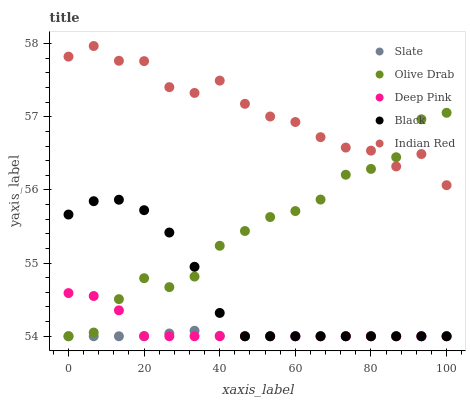Does Slate have the minimum area under the curve?
Answer yes or no. Yes. Does Indian Red have the maximum area under the curve?
Answer yes or no. Yes. Does Deep Pink have the minimum area under the curve?
Answer yes or no. No. Does Deep Pink have the maximum area under the curve?
Answer yes or no. No. Is Slate the smoothest?
Answer yes or no. Yes. Is Indian Red the roughest?
Answer yes or no. Yes. Is Deep Pink the smoothest?
Answer yes or no. No. Is Deep Pink the roughest?
Answer yes or no. No. Does Slate have the lowest value?
Answer yes or no. Yes. Does Indian Red have the lowest value?
Answer yes or no. No. Does Indian Red have the highest value?
Answer yes or no. Yes. Does Deep Pink have the highest value?
Answer yes or no. No. Is Slate less than Indian Red?
Answer yes or no. Yes. Is Indian Red greater than Deep Pink?
Answer yes or no. Yes. Does Deep Pink intersect Black?
Answer yes or no. Yes. Is Deep Pink less than Black?
Answer yes or no. No. Is Deep Pink greater than Black?
Answer yes or no. No. Does Slate intersect Indian Red?
Answer yes or no. No. 